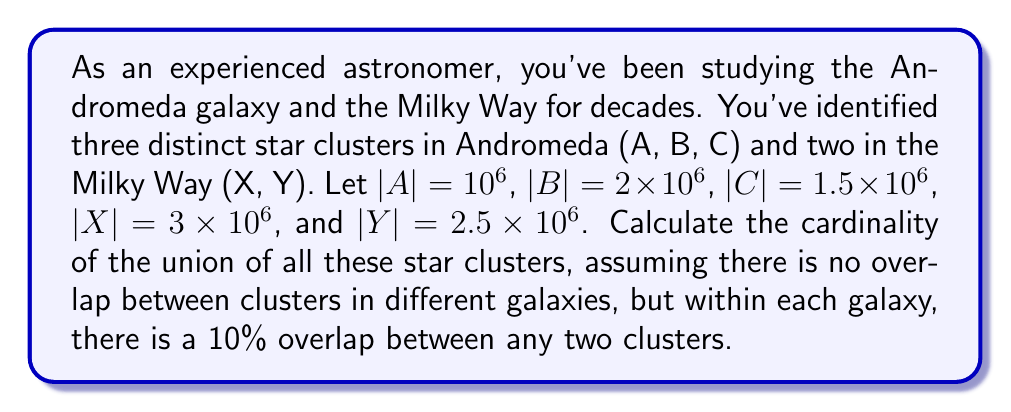Show me your answer to this math problem. Let's approach this step-by-step:

1) First, let's calculate the total number of stars in each galaxy separately, considering the overlap within each galaxy.

For Andromeda:
$$|A \cup B \cup C| = |A| + |B| + |C| - |A \cap B| - |B \cap C| - |A \cap C| + |A \cap B \cap C|$$

The overlap between any two clusters is 10% of the smaller cluster:
$|A \cap B| = 0.1 \times 10^6 = 10^5$
$|B \cap C| = 0.1 \times 1.5 \times 10^6 = 1.5 \times 10^5$
$|A \cap C| = 0.1 \times 10^6 = 10^5$

For the triple intersection, we can estimate it as 10% of the smallest pairwise intersection:
$|A \cap B \cap C| \approx 0.1 \times 10^5 = 10^4$

Now we can calculate:
$$|A \cup B \cup C| = 10^6 + 2 \times 10^6 + 1.5 \times 10^6 - 10^5 - 1.5 \times 10^5 - 10^5 + 10^4$$
$$= 4.5 \times 10^6 - 3.5 \times 10^5 + 10^4 = 4.16 \times 10^6$$

For the Milky Way:
$$|X \cup Y| = |X| + |Y| - |X \cap Y|$$
$|X \cap Y| = 0.1 \times 2.5 \times 10^6 = 2.5 \times 10^5$

$$|X \cup Y| = 3 \times 10^6 + 2.5 \times 10^6 - 2.5 \times 10^5 = 5.25 \times 10^6$$

2) Now, since there's no overlap between galaxies, we can simply add the results:

Total cardinality = $|A \cup B \cup C| + |X \cup Y|$
$$= 4.16 \times 10^6 + 5.25 \times 10^6 = 9.41 \times 10^6$$
Answer: The cardinality of the union of all star clusters is approximately $9.41 \times 10^6$ stars. 